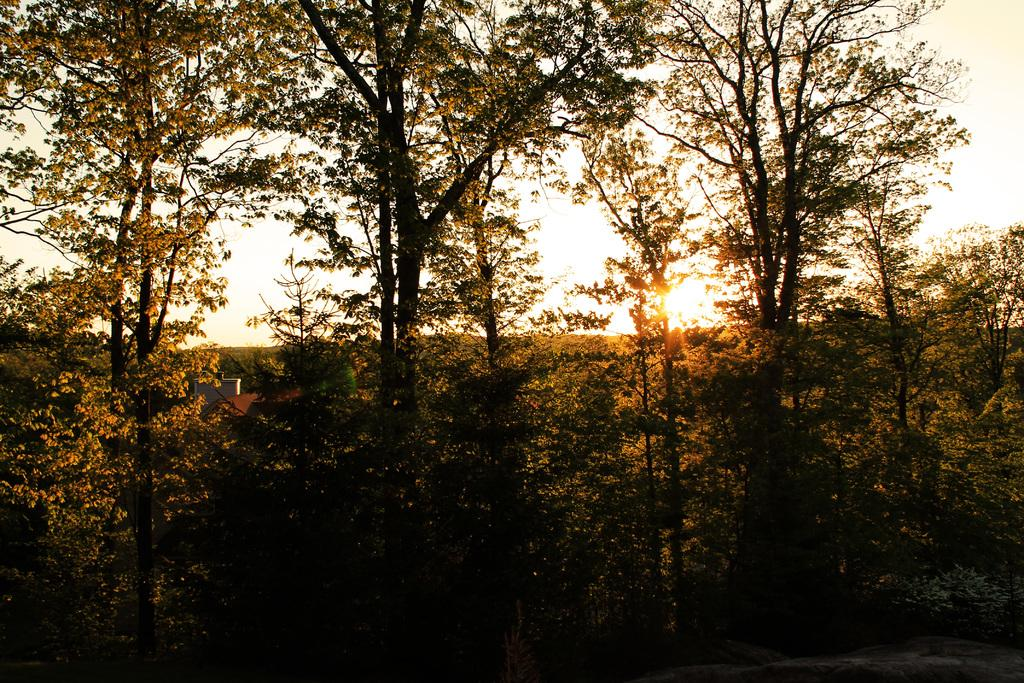What type of natural environment is depicted in the image? The image features many trees, indicating a forest or wooded area. What is visible at the top of the image? The sky is visible at the top of the image. Can you describe the lighting conditions in the image? Sunlight is present in the image, suggesting a bright and sunny day. What book is being read by the tree in the image? There are no books or trees reading in the image; it features a natural environment with trees and sunlight. 